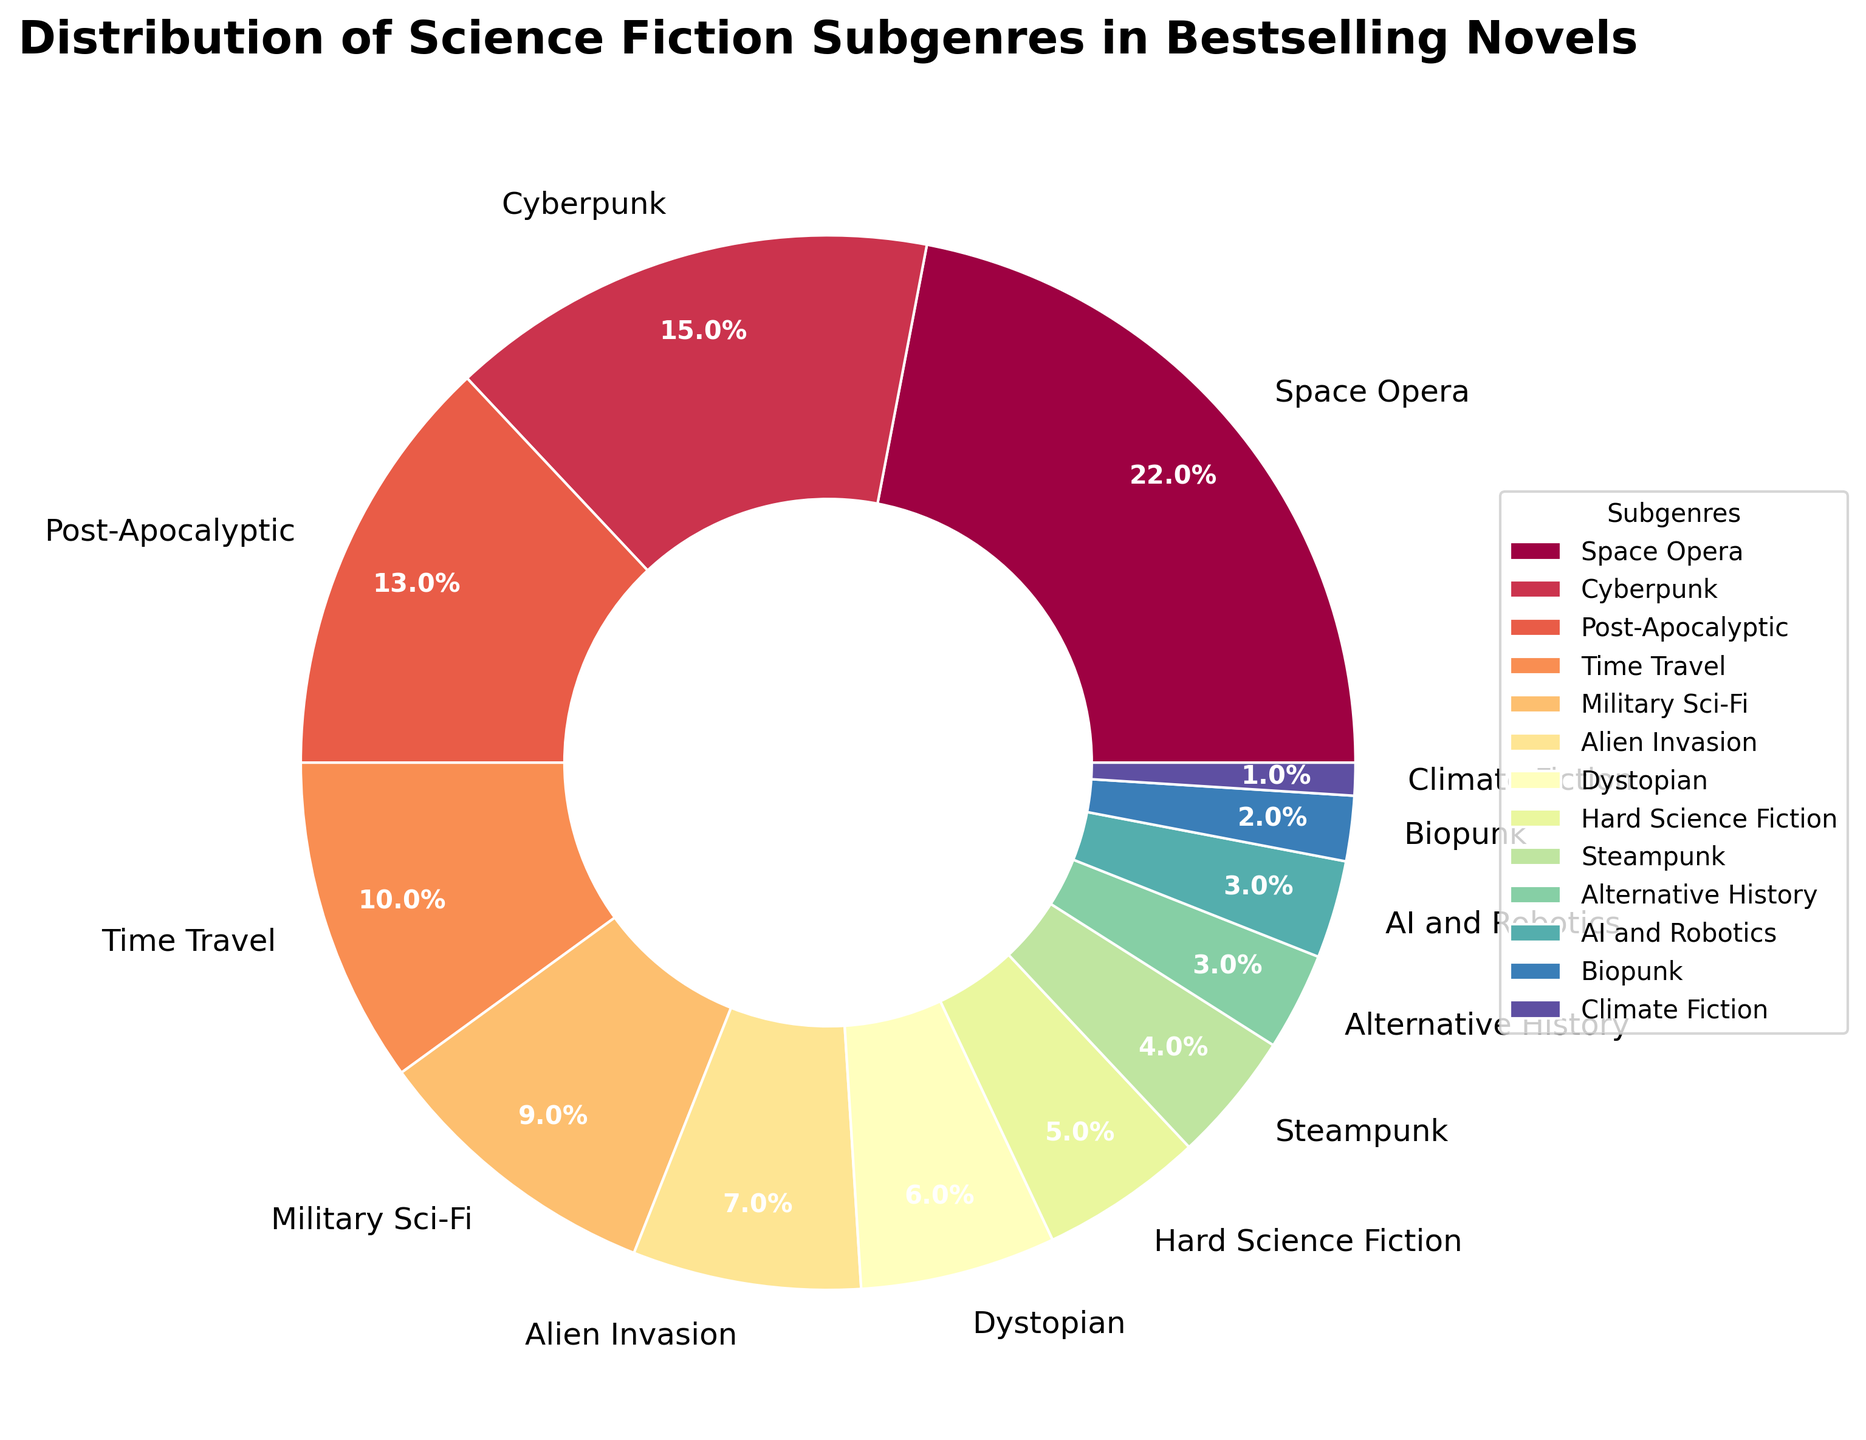What is the most represented subgenre in the bestselling novels? The figure shows that the largest slice of the pie chart is for "Space Opera" with 22%. This indicates it is the most represented subgenre.
Answer: Space Opera Which subgenre has exactly half the percentage representation as Space Opera? Space Opera represents 22%, so half of this is 11%. The closest subgenre to this value is "Time Travel," which has a 10% representation.
Answer: Time Travel What is the combined percentage representation of Cyberpunk and Post-Apocalyptic subgenres? The percentage for Cyberpunk is 15% and for Post-Apocalyptic is 13%. Adding these together: 15% + 13% = 28%.
Answer: 28% How does the percentage of Military Sci-Fi compare to the percentage of Alien Invasion? The percentage of Military Sci-Fi is 9%, while Alien Invasion is 7%. Thus, Military Sci-Fi is greater than Alien Invasion by 2%.
Answer: Military Sci-Fi is 2% greater What is the difference in representation between the most and least represented subgenres? The most represented subgenre is Space Opera at 22%, and the least represented subgenre is Climate Fiction at 1%. The difference is 22% - 1% = 21%.
Answer: 21% If you combined the percentages of the three subgenres with the smallest representation, what would be the total percentage? The three smallest subgenres are Climate Fiction (1%), Biopunk (2%), and AI and Robotics (3%). Their combined representation is 1% + 2% + 3% = 6%.
Answer: 6% Identify the subgenres with representation closest to the median value of all the subgenres' percentages. To find the median, list all percentages in ascending order: 1, 2, 3, 3, 4, 5, 6, 7, 9, 10, 13, 15, 22. The median value is the middle one, which is 6%. The subgenre with this percentage is Dystopian.
Answer: Dystopian Which subgenre's slice is visually the smallest on the pie chart? By observing the pie chart, the slice representing Climate Fiction looks the smallest, with a 1% representation.
Answer: Climate Fiction What is the combined percentage of subgenres with a representation greater than 10%? Subgenres greater than 10% are Space Opera (22%), Cyberpunk (15%), and Post-Apocalyptic (13%). Combined, they make 22% + 15% + 13% = 50%.
Answer: 50% 